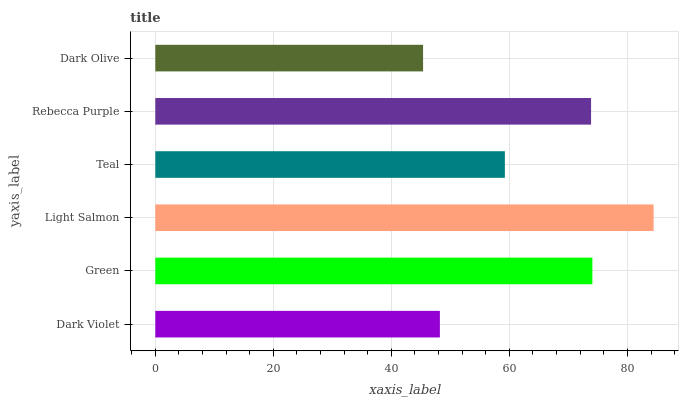Is Dark Olive the minimum?
Answer yes or no. Yes. Is Light Salmon the maximum?
Answer yes or no. Yes. Is Green the minimum?
Answer yes or no. No. Is Green the maximum?
Answer yes or no. No. Is Green greater than Dark Violet?
Answer yes or no. Yes. Is Dark Violet less than Green?
Answer yes or no. Yes. Is Dark Violet greater than Green?
Answer yes or no. No. Is Green less than Dark Violet?
Answer yes or no. No. Is Rebecca Purple the high median?
Answer yes or no. Yes. Is Teal the low median?
Answer yes or no. Yes. Is Dark Olive the high median?
Answer yes or no. No. Is Dark Violet the low median?
Answer yes or no. No. 